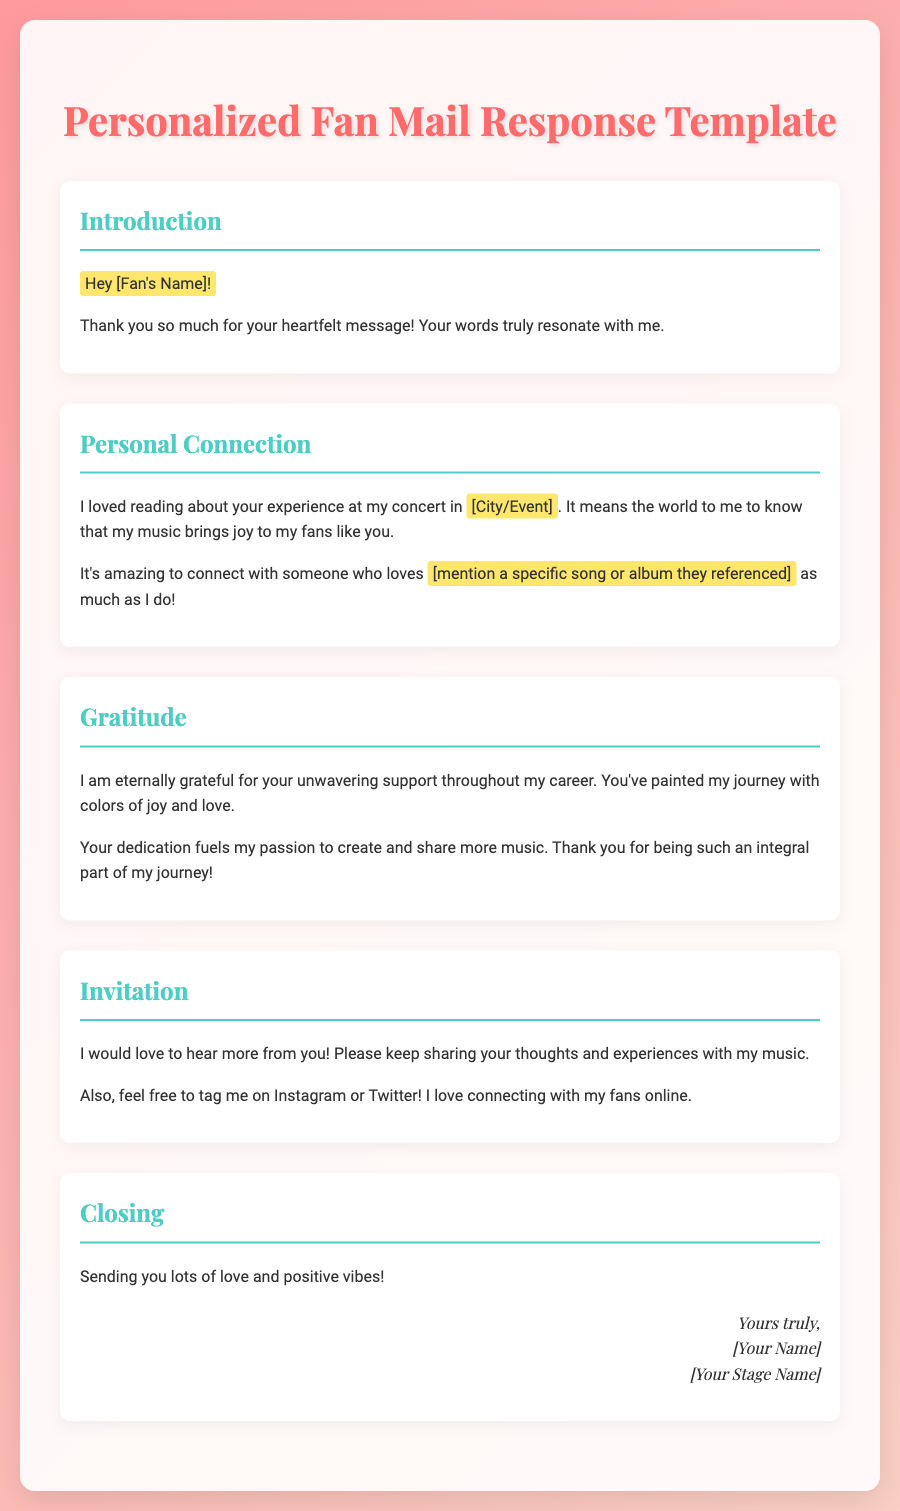What is the fan's name placeholder? The document uses a placeholder for the fan's name as [Fan's Name].
Answer: [Fan's Name] What is the highlighted city or event in the personal connection section? The personal connection section includes a placeholder for the city or event as [City/Event].
Answer: [City/Event] What does the gratitude section express about the fan's support? The gratitude section mentions that the fan's support paints the artist's journey with joy and love.
Answer: joy and love What social media platforms are mentioned for connecting with fans? The document refers to Instagram and Twitter for connecting with fans.
Answer: Instagram and Twitter What is the closing sentiment expressed in the letter? The closing sentiment expresses sending lots of love and positive vibes.
Answer: love and positive vibes How does the document emphasize the fan's impact on the artist? The gratitude section explains that the fan's dedication fuels the artist's passion to create music.
Answer: fuels my passion What song or album is suggested to be referenced by the fan? The document includes a placeholder for a song or album as [mention a specific song or album they referenced].
Answer: [mention a specific song or album they referenced] What type of document is this? This document is a template for personalized fan mail responses.
Answer: template for personalized fan mail responses 